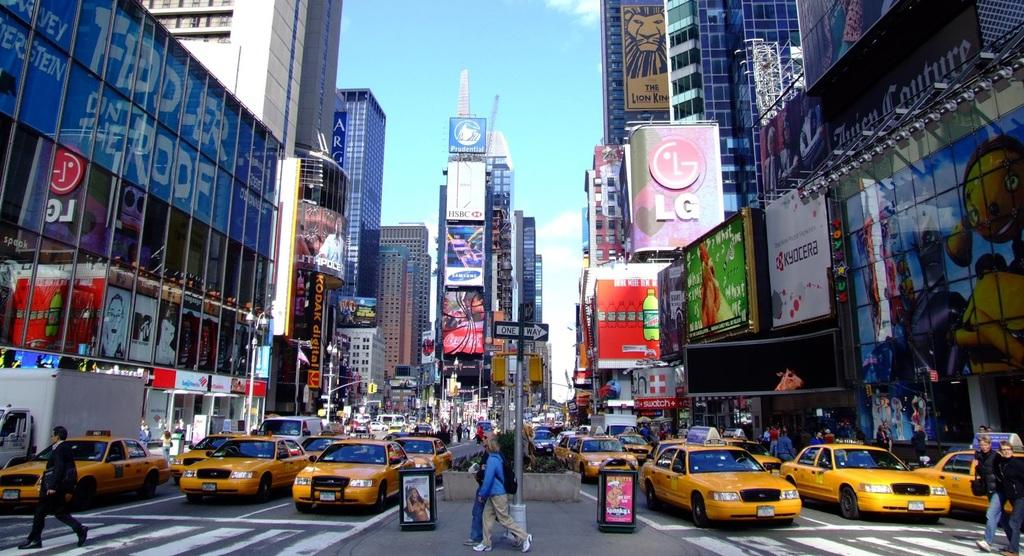<image>
Give a short and clear explanation of the subsequent image. Many taxis driving in a busy city with advertisements everywhere including one for LG. 